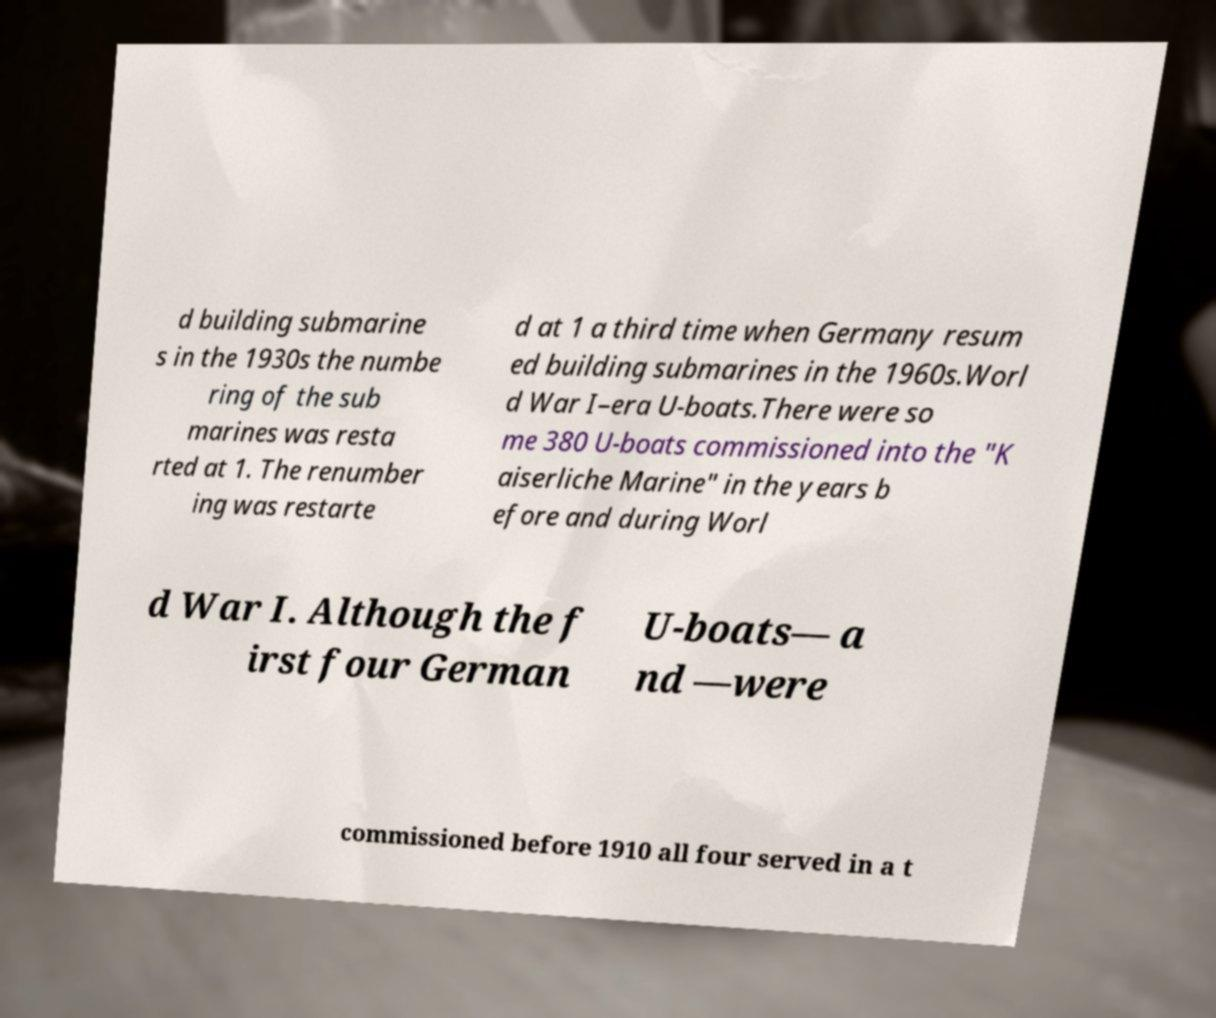What messages or text are displayed in this image? I need them in a readable, typed format. d building submarine s in the 1930s the numbe ring of the sub marines was resta rted at 1. The renumber ing was restarte d at 1 a third time when Germany resum ed building submarines in the 1960s.Worl d War I–era U-boats.There were so me 380 U-boats commissioned into the "K aiserliche Marine" in the years b efore and during Worl d War I. Although the f irst four German U-boats— a nd —were commissioned before 1910 all four served in a t 